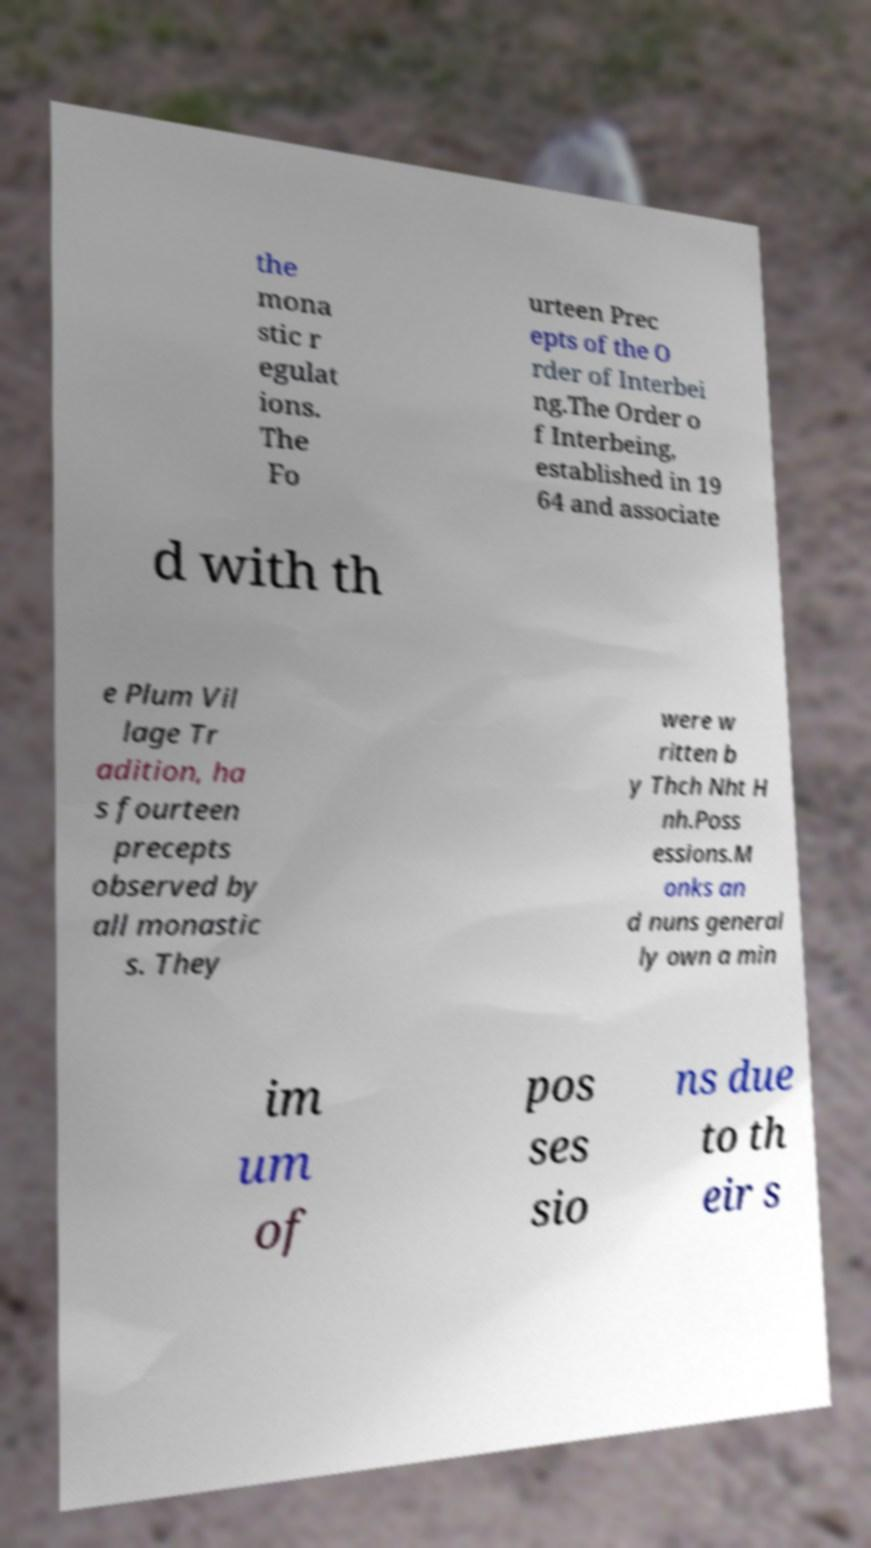Please read and relay the text visible in this image. What does it say? the mona stic r egulat ions. The Fo urteen Prec epts of the O rder of Interbei ng.The Order o f Interbeing, established in 19 64 and associate d with th e Plum Vil lage Tr adition, ha s fourteen precepts observed by all monastic s. They were w ritten b y Thch Nht H nh.Poss essions.M onks an d nuns general ly own a min im um of pos ses sio ns due to th eir s 